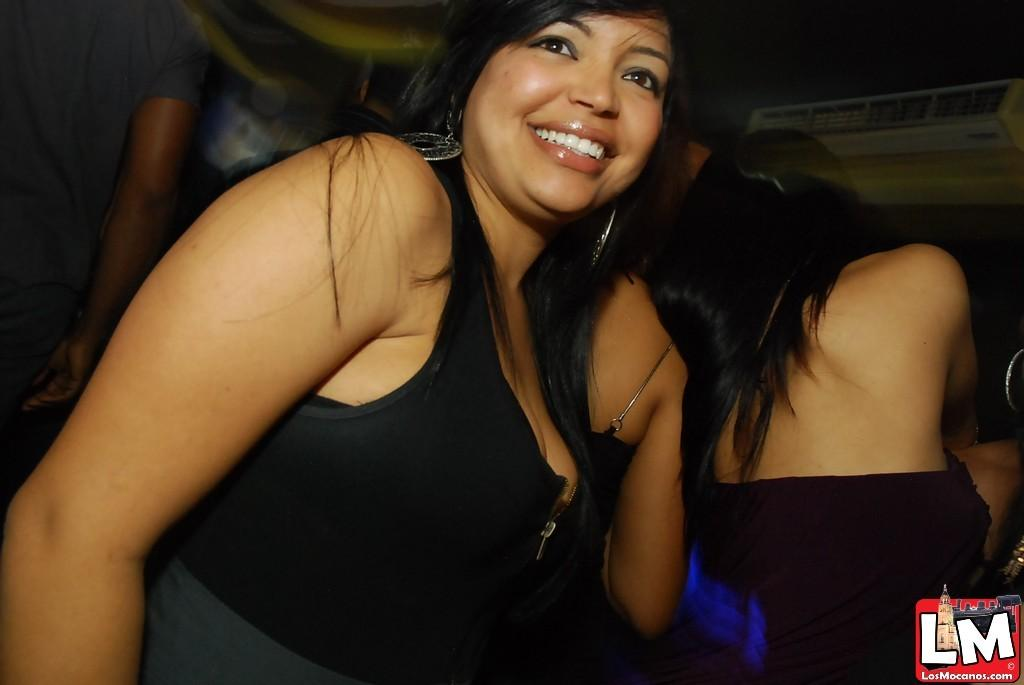<image>
Provide a brief description of the given image. A woman is smiling and the image can be found on LosMocanos.com. 